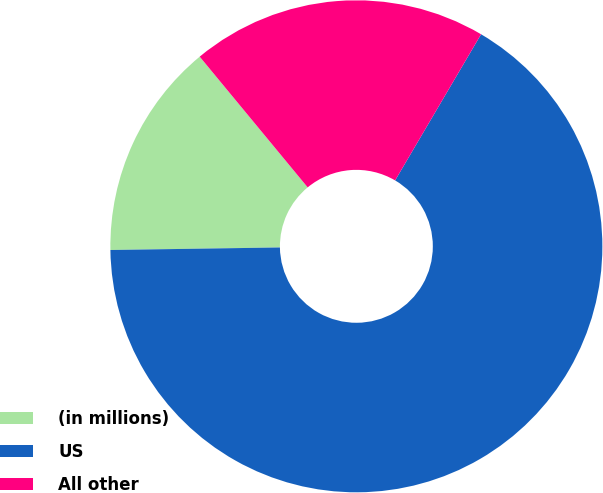<chart> <loc_0><loc_0><loc_500><loc_500><pie_chart><fcel>(in millions)<fcel>US<fcel>All other<nl><fcel>14.25%<fcel>66.3%<fcel>19.45%<nl></chart> 